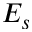Convert formula to latex. <formula><loc_0><loc_0><loc_500><loc_500>E _ { s }</formula> 